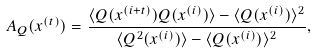Convert formula to latex. <formula><loc_0><loc_0><loc_500><loc_500>A _ { Q } ( x ^ { ( t ) } ) = \frac { \langle Q ( x ^ { ( i + t ) } ) Q ( x ^ { ( i ) } ) \rangle - \langle Q ( x ^ { ( i ) } ) \rangle ^ { 2 } } { \langle Q ^ { 2 } ( x ^ { ( i ) } ) \rangle - \langle Q ( x ^ { ( i ) } ) \rangle ^ { 2 } } ,</formula> 